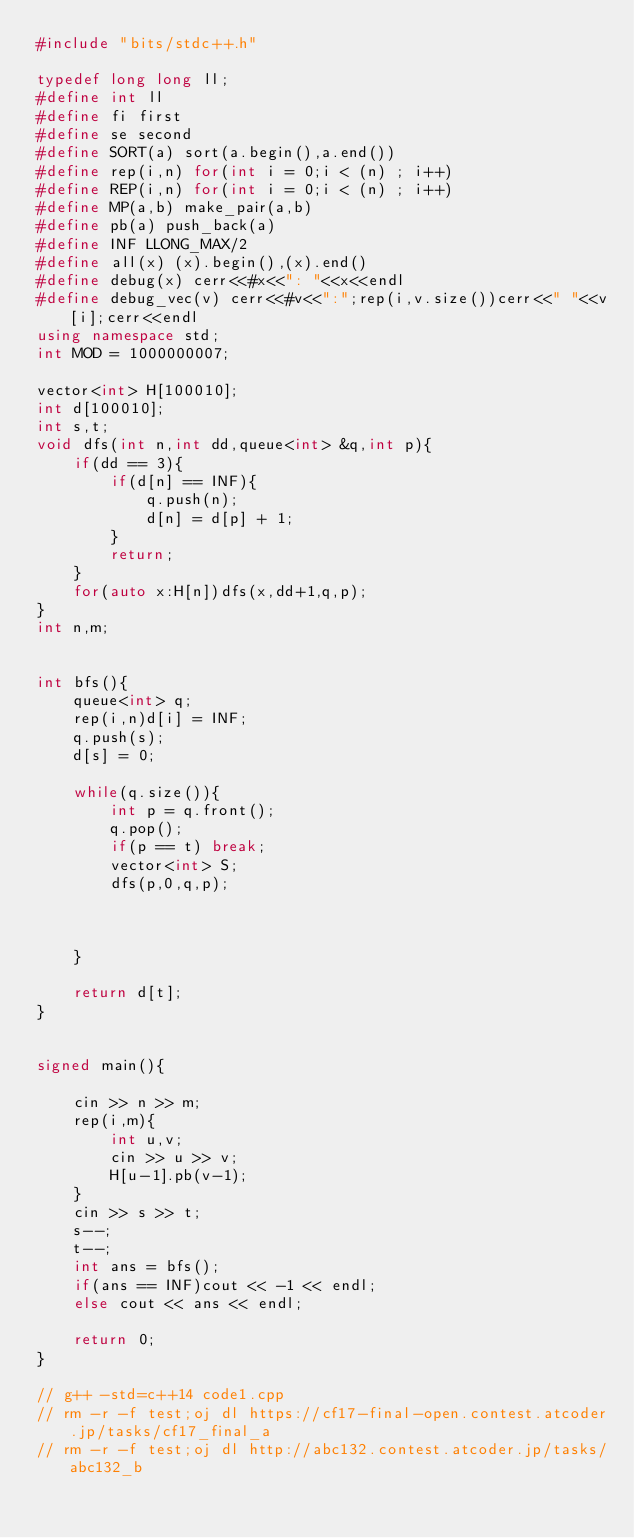Convert code to text. <code><loc_0><loc_0><loc_500><loc_500><_C++_>#include "bits/stdc++.h"
 
typedef long long ll;
#define int ll
#define fi first
#define se second
#define SORT(a) sort(a.begin(),a.end())
#define rep(i,n) for(int i = 0;i < (n) ; i++) 
#define REP(i,n) for(int i = 0;i < (n) ; i++) 
#define MP(a,b) make_pair(a,b)
#define pb(a) push_back(a)
#define INF LLONG_MAX/2
#define all(x) (x).begin(),(x).end()
#define debug(x) cerr<<#x<<": "<<x<<endl
#define debug_vec(v) cerr<<#v<<":";rep(i,v.size())cerr<<" "<<v[i];cerr<<endl
using namespace std;
int MOD = 1000000007;

vector<int> H[100010];
int d[100010];
int s,t;
void dfs(int n,int dd,queue<int> &q,int p){
    if(dd == 3){
        if(d[n] == INF){
            q.push(n);
            d[n] = d[p] + 1;
        }
        return;
    }
    for(auto x:H[n])dfs(x,dd+1,q,p);
}
int n,m;


int bfs(){
    queue<int> q;
    rep(i,n)d[i] = INF;
    q.push(s);
    d[s] = 0;

    while(q.size()){
        int p = q.front();
        q.pop();
        if(p == t) break;
        vector<int> S;
        dfs(p,0,q,p);

        
        
    }
    
    return d[t];
}


signed main(){
    
    cin >> n >> m;
    rep(i,m){
        int u,v;
        cin >> u >> v;
        H[u-1].pb(v-1);
    }
    cin >> s >> t;
    s--;
    t--;
    int ans = bfs();
    if(ans == INF)cout << -1 << endl;
    else cout << ans << endl;

    return 0;
}

// g++ -std=c++14 code1.cpp
// rm -r -f test;oj dl https://cf17-final-open.contest.atcoder.jp/tasks/cf17_final_a
// rm -r -f test;oj dl http://abc132.contest.atcoder.jp/tasks/abc132_b</code> 